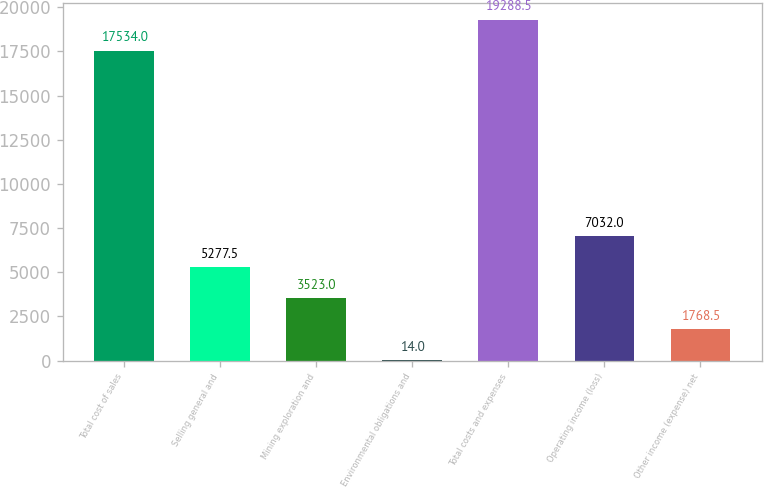Convert chart to OTSL. <chart><loc_0><loc_0><loc_500><loc_500><bar_chart><fcel>Total cost of sales<fcel>Selling general and<fcel>Mining exploration and<fcel>Environmental obligations and<fcel>Total costs and expenses<fcel>Operating income (loss)<fcel>Other income (expense) net<nl><fcel>17534<fcel>5277.5<fcel>3523<fcel>14<fcel>19288.5<fcel>7032<fcel>1768.5<nl></chart> 